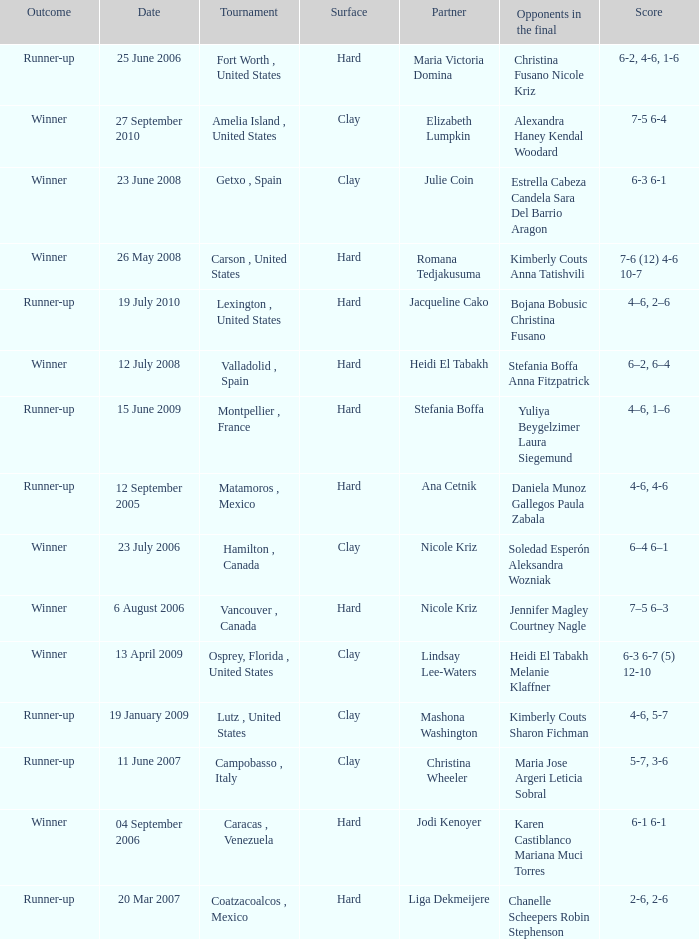Who were the opponents during the final when christina wheeler was partner? Maria Jose Argeri Leticia Sobral. 